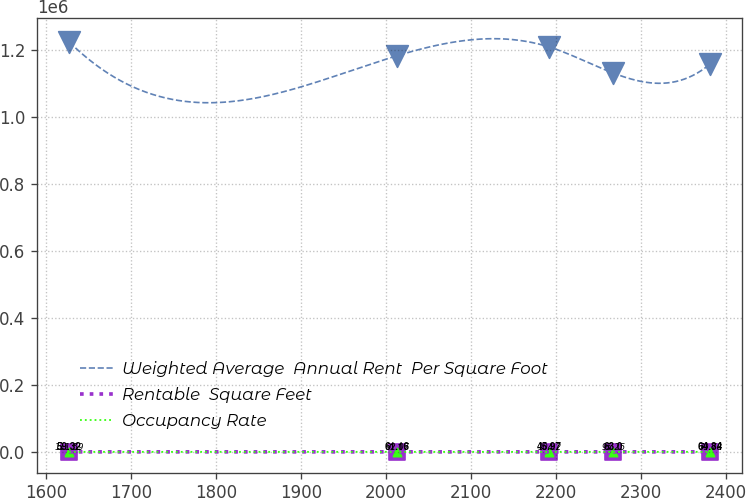Convert chart to OTSL. <chart><loc_0><loc_0><loc_500><loc_500><line_chart><ecel><fcel>Weighted Average  Annual Rent  Per Square Foot<fcel>Rentable  Square Feet<fcel>Occupancy Rate<nl><fcel>1627.25<fcel>1.22307e+06<fcel>111.59<fcel>59.32<nl><fcel>2013.61<fcel>1.18187e+06<fcel>92.07<fcel>61.16<nl><fcel>2191.68<fcel>1.20799e+06<fcel>104.2<fcel>45.97<nl><fcel>2267.1<fcel>1.13027e+06<fcel>95.25<fcel>63<nl><fcel>2381.45<fcel>1.15683e+06<fcel>79.78<fcel>64.84<nl></chart> 